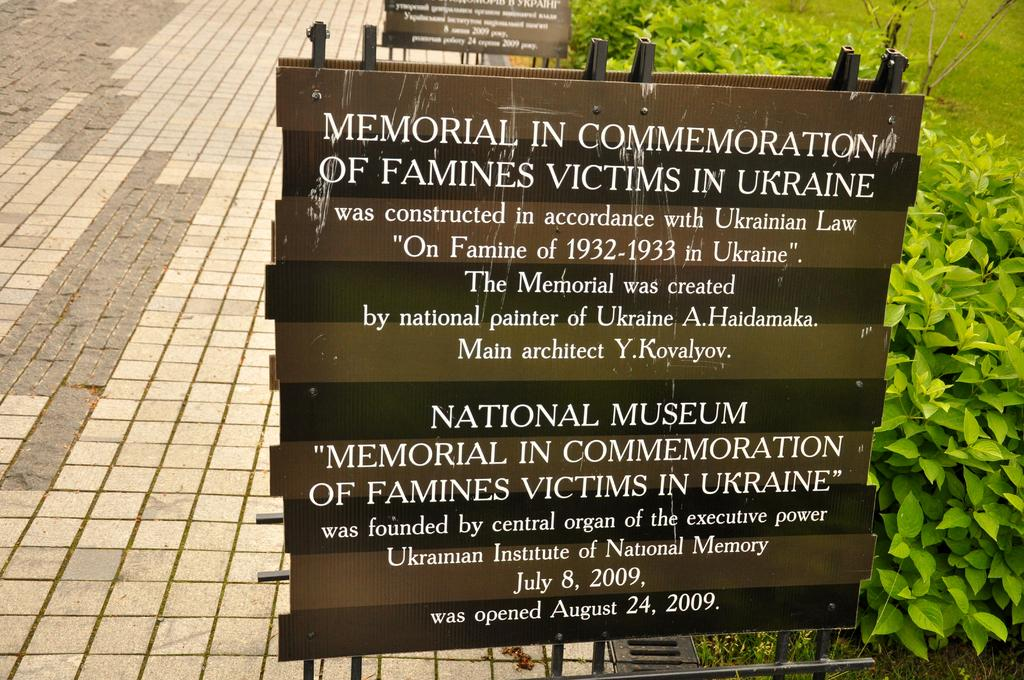What type of signage is present in the image? There are information boards in the image. What can be seen on the right side of the image? There are plants and grass on the right side of the image. What type of polish is being applied to the horn in the image? There is no polish or horn present in the image. What type of iron is being used to press the plants in the image? There is no iron present in the image, and plants are not being pressed. 